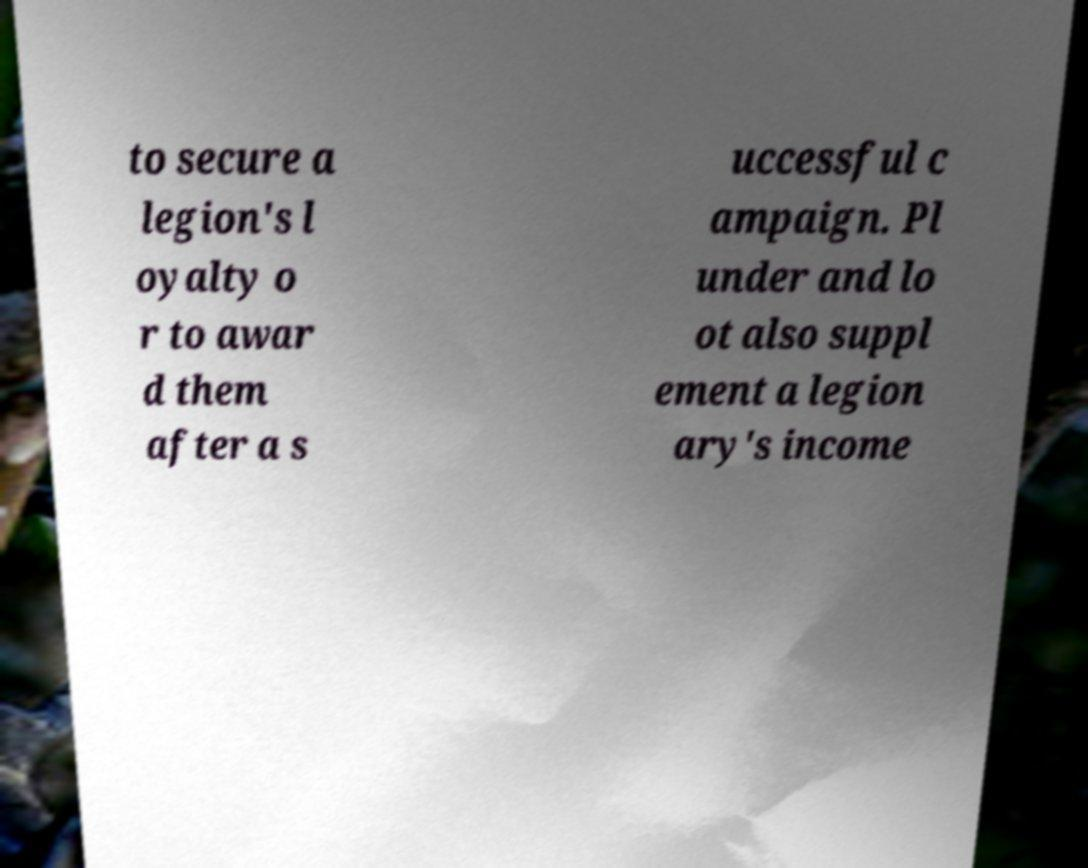For documentation purposes, I need the text within this image transcribed. Could you provide that? to secure a legion's l oyalty o r to awar d them after a s uccessful c ampaign. Pl under and lo ot also suppl ement a legion ary's income 